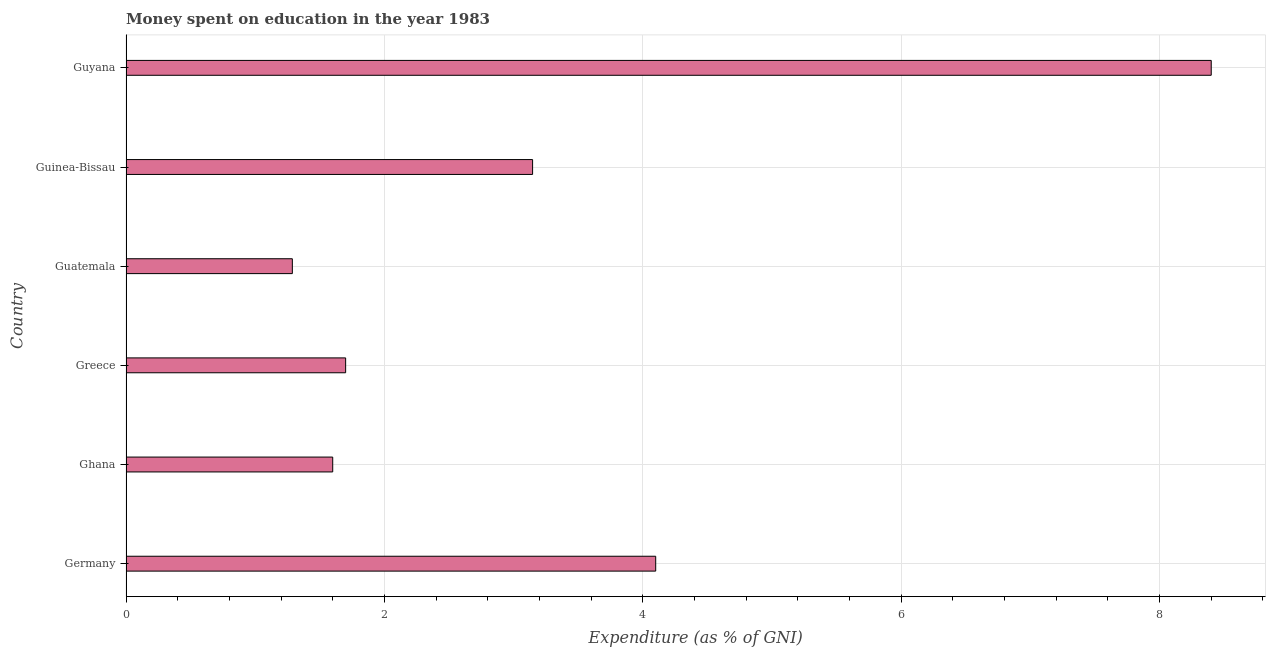What is the title of the graph?
Offer a very short reply. Money spent on education in the year 1983. What is the label or title of the X-axis?
Offer a very short reply. Expenditure (as % of GNI). What is the label or title of the Y-axis?
Your answer should be very brief. Country. What is the expenditure on education in Guatemala?
Give a very brief answer. 1.29. Across all countries, what is the maximum expenditure on education?
Offer a terse response. 8.4. Across all countries, what is the minimum expenditure on education?
Provide a short and direct response. 1.29. In which country was the expenditure on education maximum?
Make the answer very short. Guyana. In which country was the expenditure on education minimum?
Your response must be concise. Guatemala. What is the sum of the expenditure on education?
Your answer should be compact. 20.23. What is the difference between the expenditure on education in Germany and Guyana?
Your answer should be very brief. -4.3. What is the average expenditure on education per country?
Offer a very short reply. 3.37. What is the median expenditure on education?
Provide a succinct answer. 2.42. What is the ratio of the expenditure on education in Germany to that in Ghana?
Keep it short and to the point. 2.56. What is the difference between the highest and the second highest expenditure on education?
Your answer should be compact. 4.3. What is the difference between the highest and the lowest expenditure on education?
Offer a very short reply. 7.11. In how many countries, is the expenditure on education greater than the average expenditure on education taken over all countries?
Make the answer very short. 2. How many bars are there?
Your answer should be very brief. 6. Are all the bars in the graph horizontal?
Provide a succinct answer. Yes. How many countries are there in the graph?
Keep it short and to the point. 6. What is the difference between two consecutive major ticks on the X-axis?
Ensure brevity in your answer.  2. Are the values on the major ticks of X-axis written in scientific E-notation?
Offer a very short reply. No. What is the Expenditure (as % of GNI) in Ghana?
Your answer should be very brief. 1.6. What is the Expenditure (as % of GNI) in Greece?
Your answer should be compact. 1.7. What is the Expenditure (as % of GNI) of Guatemala?
Keep it short and to the point. 1.29. What is the Expenditure (as % of GNI) in Guinea-Bissau?
Keep it short and to the point. 3.15. What is the Expenditure (as % of GNI) of Guyana?
Offer a very short reply. 8.4. What is the difference between the Expenditure (as % of GNI) in Germany and Ghana?
Offer a terse response. 2.5. What is the difference between the Expenditure (as % of GNI) in Germany and Guatemala?
Provide a short and direct response. 2.81. What is the difference between the Expenditure (as % of GNI) in Germany and Guinea-Bissau?
Your response must be concise. 0.95. What is the difference between the Expenditure (as % of GNI) in Ghana and Greece?
Your answer should be compact. -0.1. What is the difference between the Expenditure (as % of GNI) in Ghana and Guatemala?
Offer a very short reply. 0.31. What is the difference between the Expenditure (as % of GNI) in Ghana and Guinea-Bissau?
Provide a short and direct response. -1.55. What is the difference between the Expenditure (as % of GNI) in Ghana and Guyana?
Provide a short and direct response. -6.8. What is the difference between the Expenditure (as % of GNI) in Greece and Guatemala?
Make the answer very short. 0.41. What is the difference between the Expenditure (as % of GNI) in Greece and Guinea-Bissau?
Your answer should be very brief. -1.45. What is the difference between the Expenditure (as % of GNI) in Greece and Guyana?
Your answer should be very brief. -6.7. What is the difference between the Expenditure (as % of GNI) in Guatemala and Guinea-Bissau?
Offer a terse response. -1.86. What is the difference between the Expenditure (as % of GNI) in Guatemala and Guyana?
Offer a very short reply. -7.11. What is the difference between the Expenditure (as % of GNI) in Guinea-Bissau and Guyana?
Ensure brevity in your answer.  -5.25. What is the ratio of the Expenditure (as % of GNI) in Germany to that in Ghana?
Keep it short and to the point. 2.56. What is the ratio of the Expenditure (as % of GNI) in Germany to that in Greece?
Provide a succinct answer. 2.41. What is the ratio of the Expenditure (as % of GNI) in Germany to that in Guatemala?
Your answer should be very brief. 3.18. What is the ratio of the Expenditure (as % of GNI) in Germany to that in Guinea-Bissau?
Keep it short and to the point. 1.3. What is the ratio of the Expenditure (as % of GNI) in Germany to that in Guyana?
Provide a short and direct response. 0.49. What is the ratio of the Expenditure (as % of GNI) in Ghana to that in Greece?
Your answer should be very brief. 0.94. What is the ratio of the Expenditure (as % of GNI) in Ghana to that in Guatemala?
Offer a terse response. 1.24. What is the ratio of the Expenditure (as % of GNI) in Ghana to that in Guinea-Bissau?
Make the answer very short. 0.51. What is the ratio of the Expenditure (as % of GNI) in Ghana to that in Guyana?
Provide a short and direct response. 0.19. What is the ratio of the Expenditure (as % of GNI) in Greece to that in Guatemala?
Offer a very short reply. 1.32. What is the ratio of the Expenditure (as % of GNI) in Greece to that in Guinea-Bissau?
Your answer should be very brief. 0.54. What is the ratio of the Expenditure (as % of GNI) in Greece to that in Guyana?
Your answer should be compact. 0.2. What is the ratio of the Expenditure (as % of GNI) in Guatemala to that in Guinea-Bissau?
Provide a succinct answer. 0.41. What is the ratio of the Expenditure (as % of GNI) in Guatemala to that in Guyana?
Give a very brief answer. 0.15. What is the ratio of the Expenditure (as % of GNI) in Guinea-Bissau to that in Guyana?
Your answer should be compact. 0.38. 